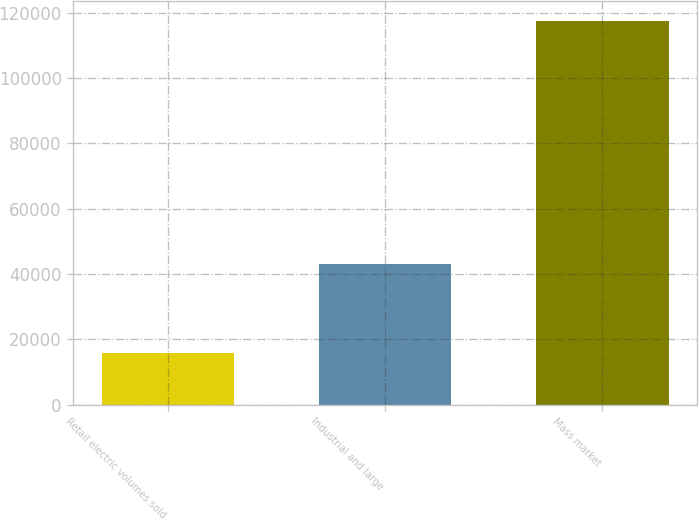Convert chart. <chart><loc_0><loc_0><loc_500><loc_500><bar_chart><fcel>Retail electric volumes sold<fcel>Industrial and large<fcel>Mass market<nl><fcel>15725<fcel>42983<fcel>117635<nl></chart> 